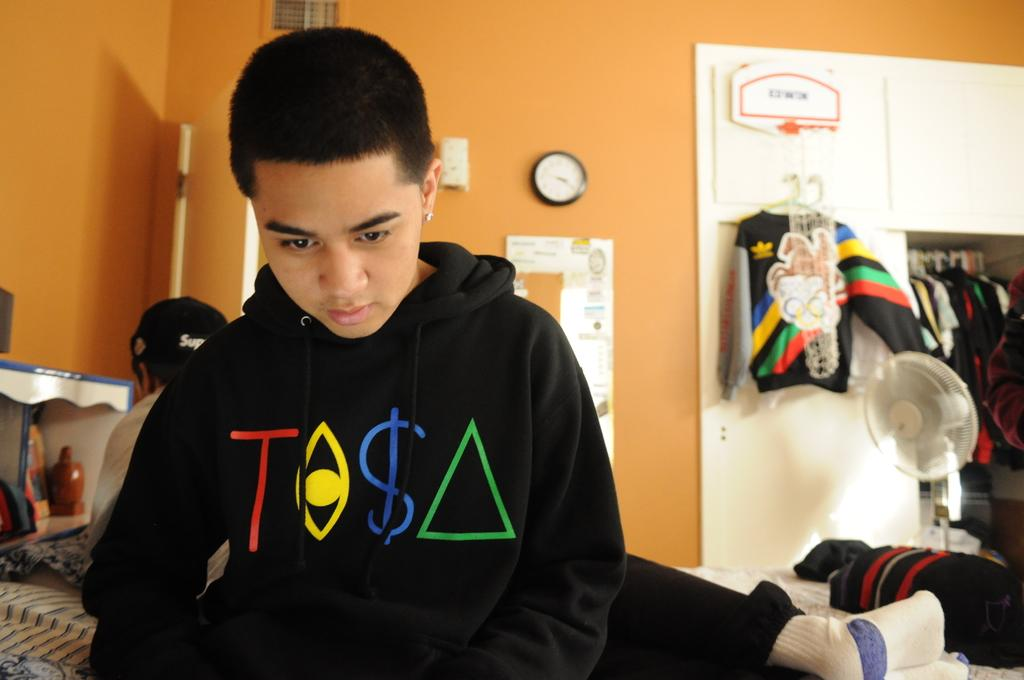Provide a one-sentence caption for the provided image. boy in bedroom wearing black sweatshirt that has a red T and blue $ on it. 